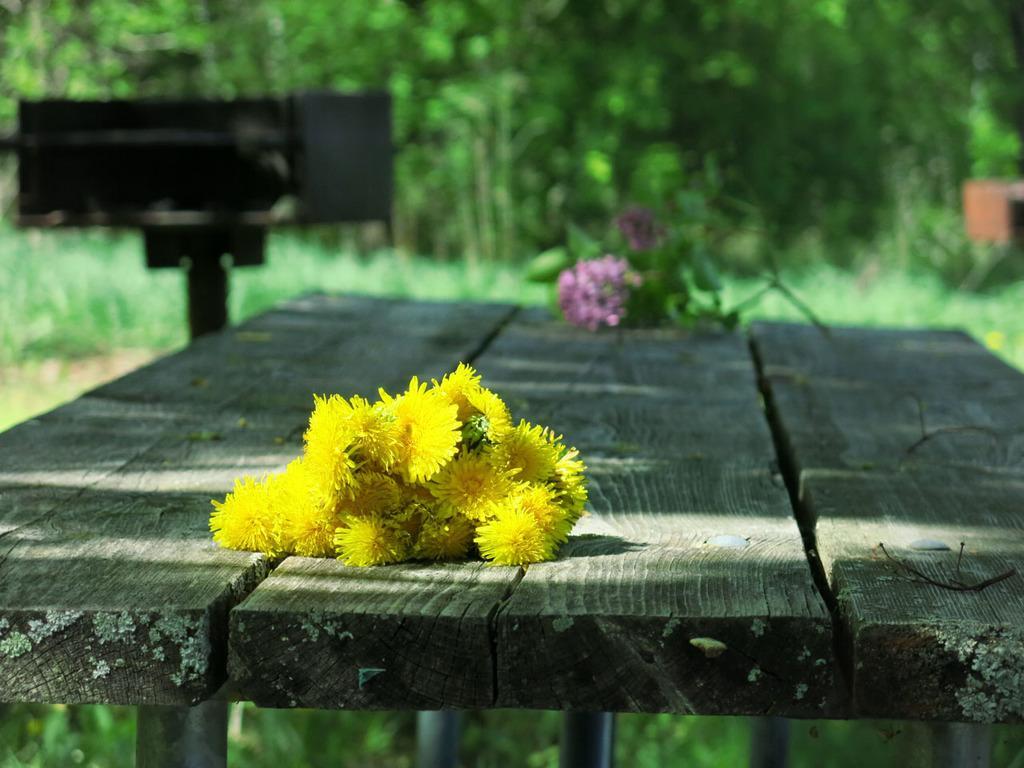In one or two sentences, can you explain what this image depicts? In this image in the front there are flowers on the bench. In the center there is an object which is black in colour and there are flowers. In the background there are trees and plants. 